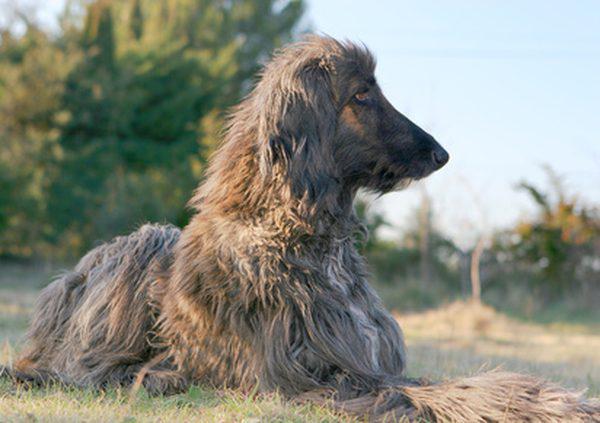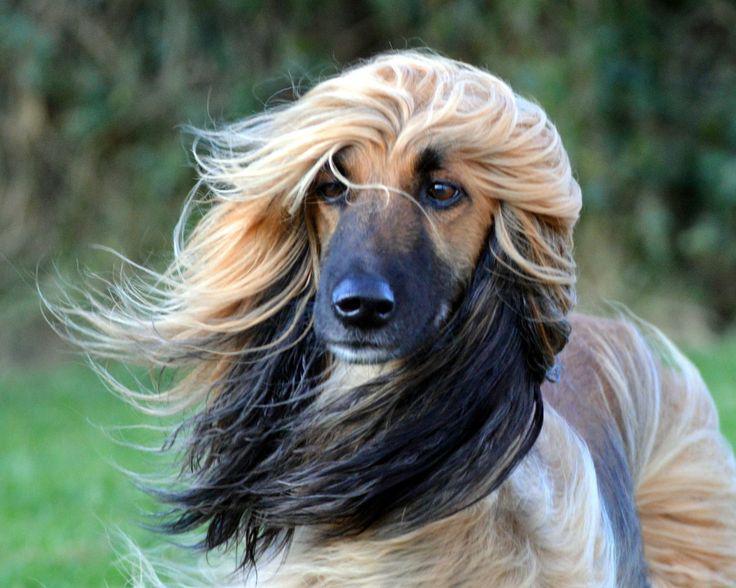The first image is the image on the left, the second image is the image on the right. Analyze the images presented: Is the assertion "Both images feature a dog wearing a head scarf." valid? Answer yes or no. No. The first image is the image on the left, the second image is the image on the right. Analyze the images presented: Is the assertion "Each image shows an afghan hound wearing a wrap that covers its neck, ears and the top of its head." valid? Answer yes or no. No. 